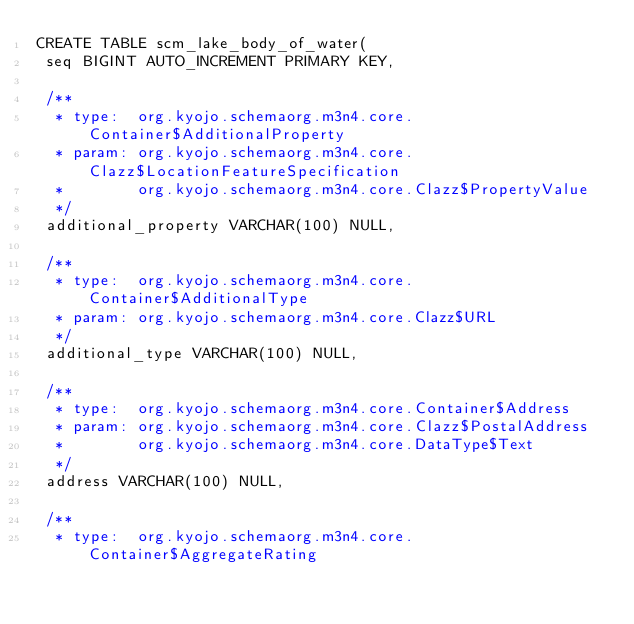<code> <loc_0><loc_0><loc_500><loc_500><_SQL_>CREATE TABLE scm_lake_body_of_water(
 seq BIGINT AUTO_INCREMENT PRIMARY KEY,

 /**
  * type:  org.kyojo.schemaorg.m3n4.core.Container$AdditionalProperty
  * param: org.kyojo.schemaorg.m3n4.core.Clazz$LocationFeatureSpecification
  *        org.kyojo.schemaorg.m3n4.core.Clazz$PropertyValue
  */
 additional_property VARCHAR(100) NULL,

 /**
  * type:  org.kyojo.schemaorg.m3n4.core.Container$AdditionalType
  * param: org.kyojo.schemaorg.m3n4.core.Clazz$URL
  */
 additional_type VARCHAR(100) NULL,

 /**
  * type:  org.kyojo.schemaorg.m3n4.core.Container$Address
  * param: org.kyojo.schemaorg.m3n4.core.Clazz$PostalAddress
  *        org.kyojo.schemaorg.m3n4.core.DataType$Text
  */
 address VARCHAR(100) NULL,

 /**
  * type:  org.kyojo.schemaorg.m3n4.core.Container$AggregateRating</code> 